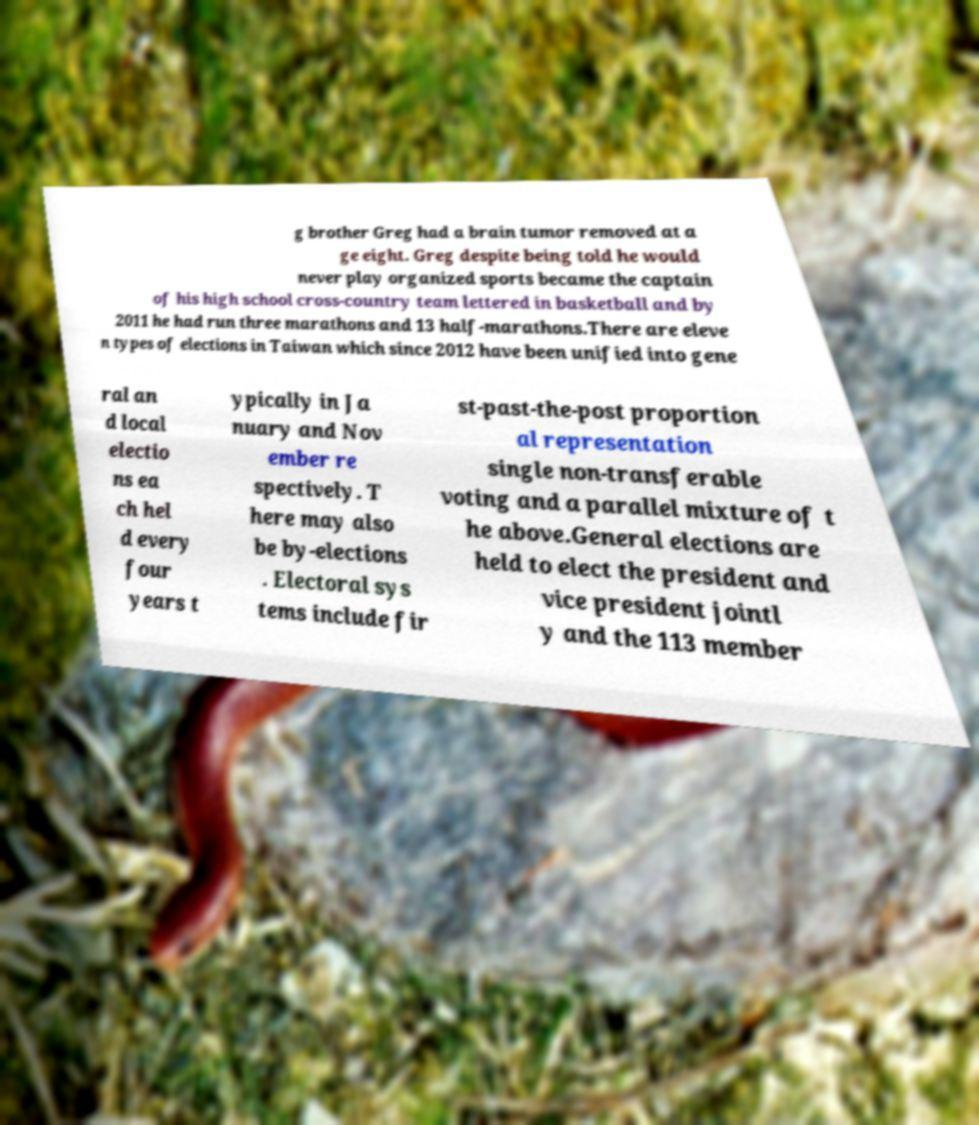There's text embedded in this image that I need extracted. Can you transcribe it verbatim? g brother Greg had a brain tumor removed at a ge eight. Greg despite being told he would never play organized sports became the captain of his high school cross-country team lettered in basketball and by 2011 he had run three marathons and 13 half-marathons.There are eleve n types of elections in Taiwan which since 2012 have been unified into gene ral an d local electio ns ea ch hel d every four years t ypically in Ja nuary and Nov ember re spectively. T here may also be by-elections . Electoral sys tems include fir st-past-the-post proportion al representation single non-transferable voting and a parallel mixture of t he above.General elections are held to elect the president and vice president jointl y and the 113 member 